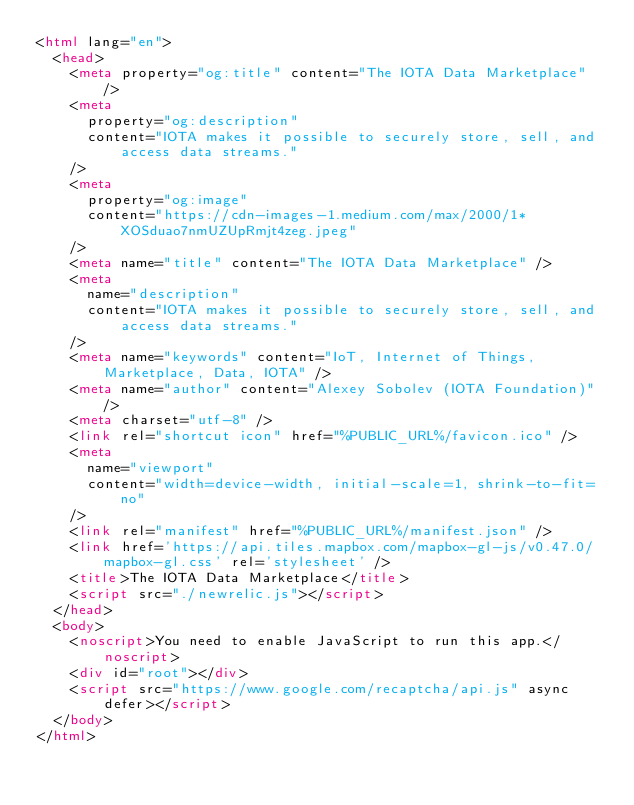<code> <loc_0><loc_0><loc_500><loc_500><_HTML_><html lang="en">
  <head>
    <meta property="og:title" content="The IOTA Data Marketplace" />
    <meta
      property="og:description"
      content="IOTA makes it possible to securely store, sell, and access data streams."
    />
    <meta
      property="og:image"
      content="https://cdn-images-1.medium.com/max/2000/1*XOSduao7nmUZUpRmjt4zeg.jpeg"
    />
    <meta name="title" content="The IOTA Data Marketplace" />
    <meta
      name="description"
      content="IOTA makes it possible to securely store, sell, and access data streams."
    />
    <meta name="keywords" content="IoT, Internet of Things, Marketplace, Data, IOTA" />
    <meta name="author" content="Alexey Sobolev (IOTA Foundation)" />
    <meta charset="utf-8" />
    <link rel="shortcut icon" href="%PUBLIC_URL%/favicon.ico" />
    <meta
      name="viewport"
      content="width=device-width, initial-scale=1, shrink-to-fit=no"
    />
    <link rel="manifest" href="%PUBLIC_URL%/manifest.json" />
    <link href='https://api.tiles.mapbox.com/mapbox-gl-js/v0.47.0/mapbox-gl.css' rel='stylesheet' />
    <title>The IOTA Data Marketplace</title>
    <script src="./newrelic.js"></script>      
  </head>
  <body>
    <noscript>You need to enable JavaScript to run this app.</noscript>
    <div id="root"></div>
    <script src="https://www.google.com/recaptcha/api.js" async defer></script>
  </body>
</html>
</code> 